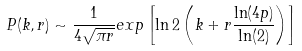<formula> <loc_0><loc_0><loc_500><loc_500>P ( k , r ) \sim \frac { 1 } { 4 \sqrt { \pi r } } e x p \left [ \ln 2 \left ( k + r \frac { \ln ( 4 p ) } { \ln ( 2 ) } \right ) \right ]</formula> 